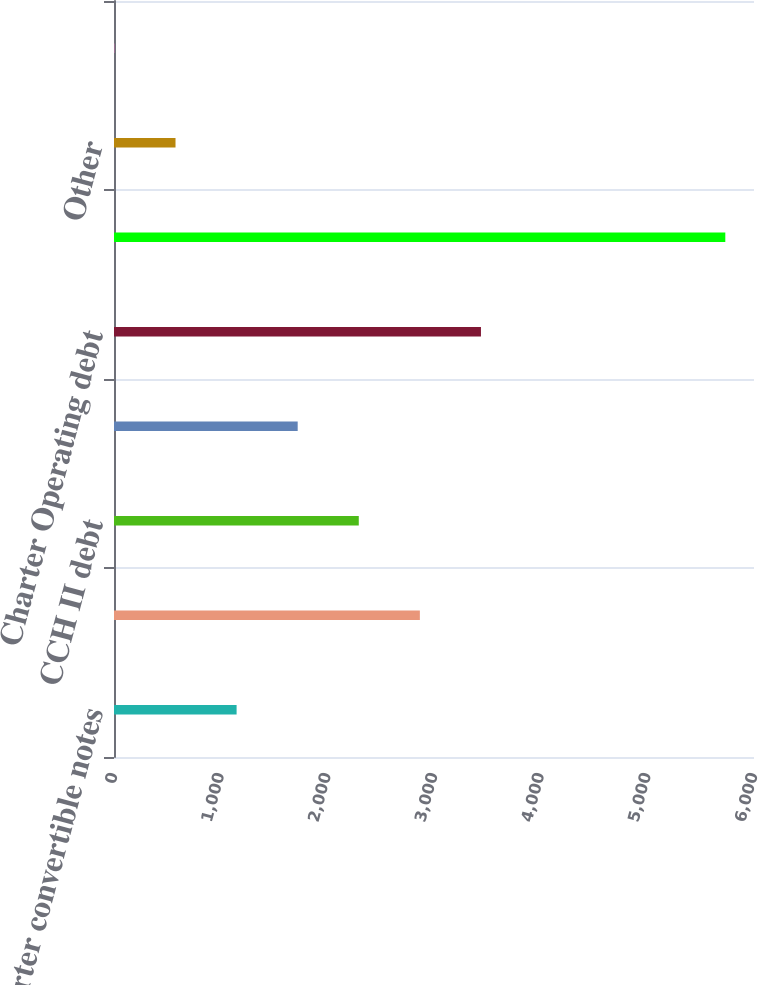Convert chart to OTSL. <chart><loc_0><loc_0><loc_500><loc_500><bar_chart><fcel>Charter convertible notes<fcel>Charter Holdings debt<fcel>CCH II debt<fcel>CCO Holdings debt<fcel>Charter Operating debt<fcel>Credit facilities<fcel>Other<fcel>Swaps<nl><fcel>1149.4<fcel>2867.5<fcel>2294.8<fcel>1722.1<fcel>3440.2<fcel>5731<fcel>576.7<fcel>4<nl></chart> 